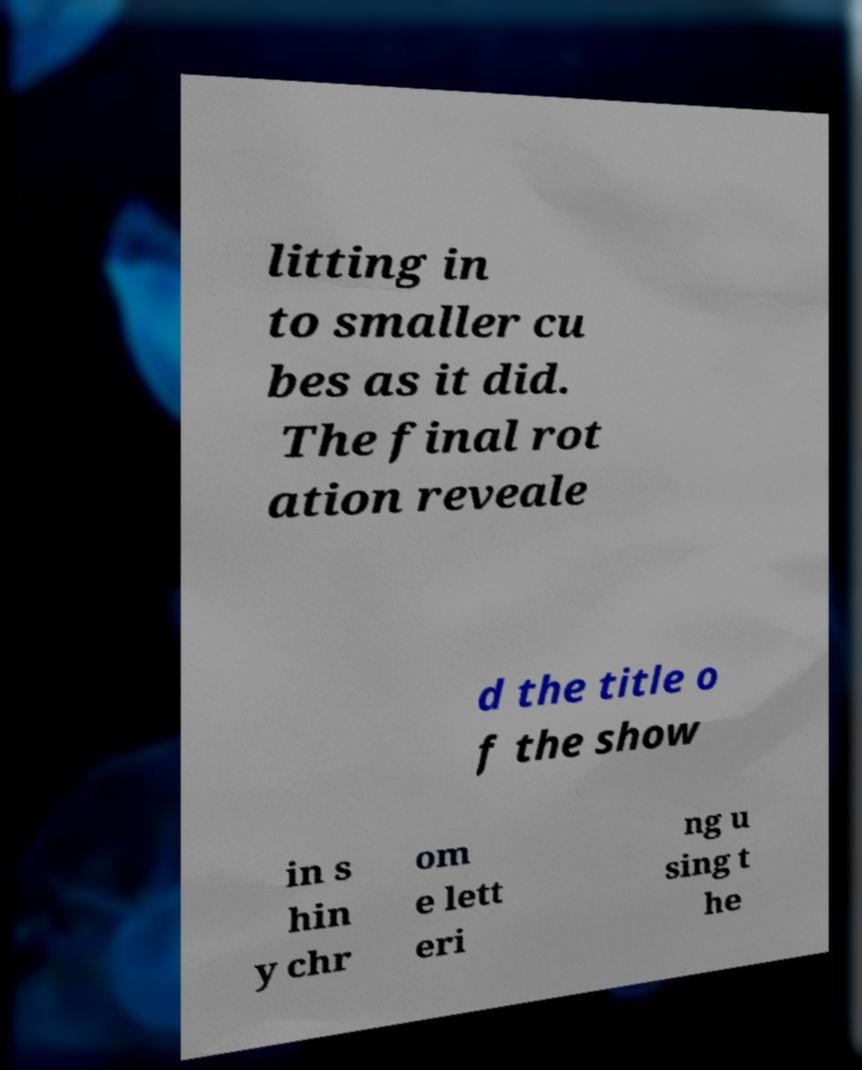Could you extract and type out the text from this image? litting in to smaller cu bes as it did. The final rot ation reveale d the title o f the show in s hin y chr om e lett eri ng u sing t he 